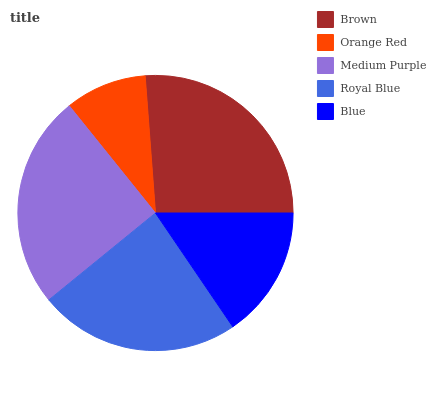Is Orange Red the minimum?
Answer yes or no. Yes. Is Brown the maximum?
Answer yes or no. Yes. Is Medium Purple the minimum?
Answer yes or no. No. Is Medium Purple the maximum?
Answer yes or no. No. Is Medium Purple greater than Orange Red?
Answer yes or no. Yes. Is Orange Red less than Medium Purple?
Answer yes or no. Yes. Is Orange Red greater than Medium Purple?
Answer yes or no. No. Is Medium Purple less than Orange Red?
Answer yes or no. No. Is Royal Blue the high median?
Answer yes or no. Yes. Is Royal Blue the low median?
Answer yes or no. Yes. Is Orange Red the high median?
Answer yes or no. No. Is Medium Purple the low median?
Answer yes or no. No. 